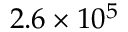Convert formula to latex. <formula><loc_0><loc_0><loc_500><loc_500>2 . 6 \times 1 0 ^ { 5 }</formula> 